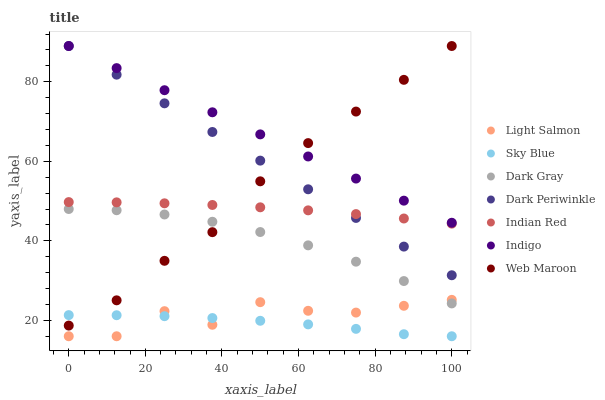Does Sky Blue have the minimum area under the curve?
Answer yes or no. Yes. Does Indigo have the maximum area under the curve?
Answer yes or no. Yes. Does Web Maroon have the minimum area under the curve?
Answer yes or no. No. Does Web Maroon have the maximum area under the curve?
Answer yes or no. No. Is Dark Periwinkle the smoothest?
Answer yes or no. Yes. Is Light Salmon the roughest?
Answer yes or no. Yes. Is Indigo the smoothest?
Answer yes or no. No. Is Indigo the roughest?
Answer yes or no. No. Does Light Salmon have the lowest value?
Answer yes or no. Yes. Does Web Maroon have the lowest value?
Answer yes or no. No. Does Dark Periwinkle have the highest value?
Answer yes or no. Yes. Does Dark Gray have the highest value?
Answer yes or no. No. Is Sky Blue less than Dark Gray?
Answer yes or no. Yes. Is Indigo greater than Dark Gray?
Answer yes or no. Yes. Does Web Maroon intersect Sky Blue?
Answer yes or no. Yes. Is Web Maroon less than Sky Blue?
Answer yes or no. No. Is Web Maroon greater than Sky Blue?
Answer yes or no. No. Does Sky Blue intersect Dark Gray?
Answer yes or no. No. 